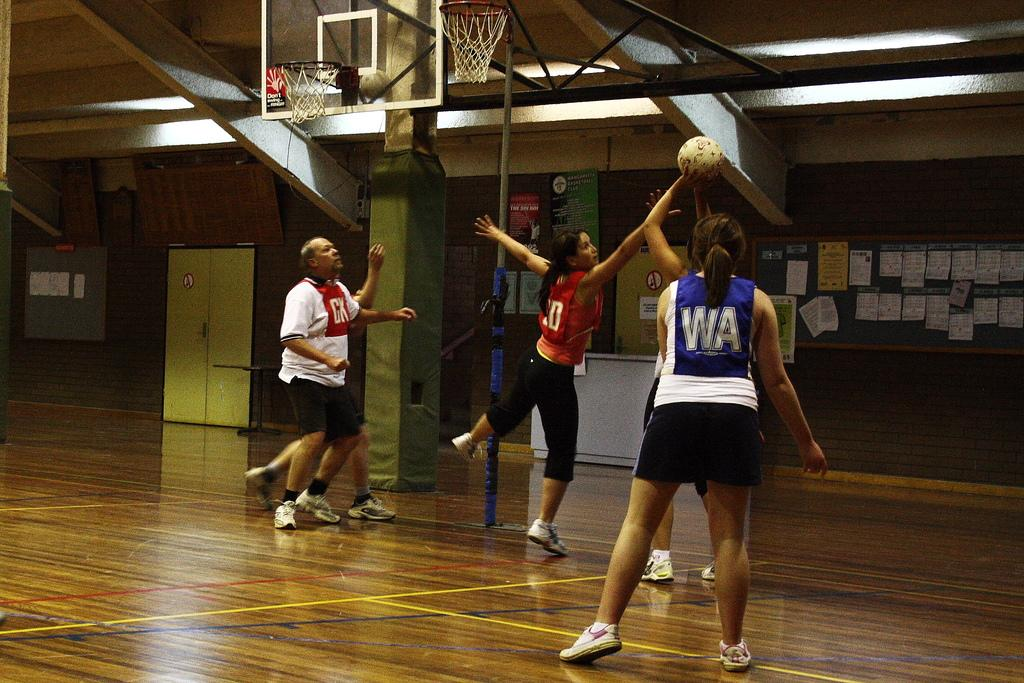<image>
Relay a brief, clear account of the picture shown. Four people playing a game of basketball and on the back on the back of a women jersey has WA and a man has CK on the front of his. 